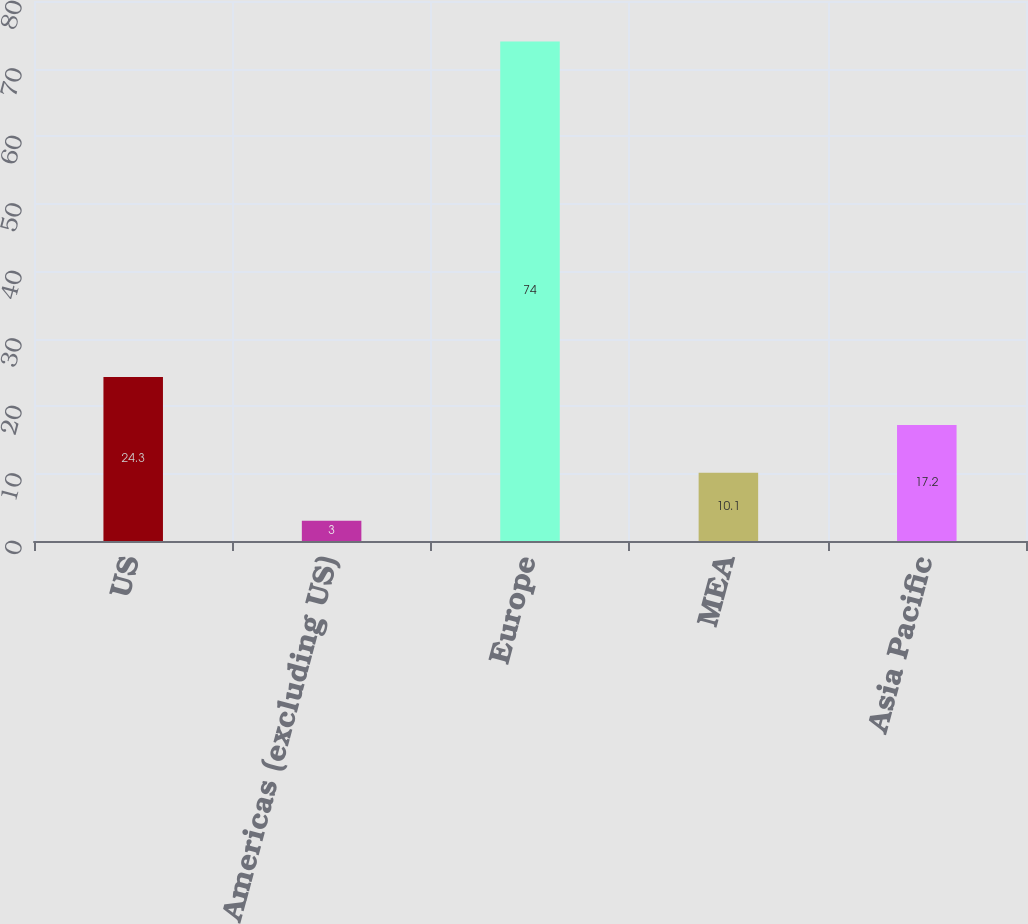Convert chart to OTSL. <chart><loc_0><loc_0><loc_500><loc_500><bar_chart><fcel>US<fcel>Americas (excluding US)<fcel>Europe<fcel>MEA<fcel>Asia Pacific<nl><fcel>24.3<fcel>3<fcel>74<fcel>10.1<fcel>17.2<nl></chart> 